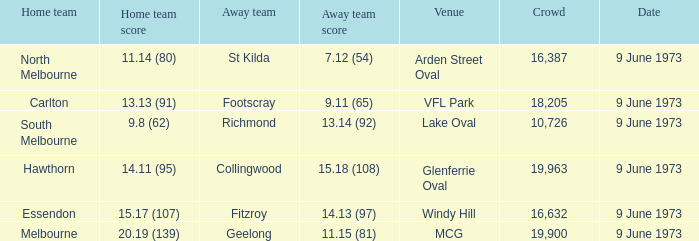What was North Melbourne's score as the home team? 11.14 (80). 